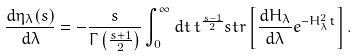Convert formula to latex. <formula><loc_0><loc_0><loc_500><loc_500>\frac { d \eta _ { \lambda } ( s ) } { d \lambda } = - \frac { s } { \Gamma \left ( \frac { s + 1 } { 2 } \right ) } \int _ { 0 } ^ { \infty } d t \, t ^ { \frac { s - 1 } { 2 } } s t r \left [ \frac { d H _ { \lambda } } { d \lambda } e ^ { - H _ { \lambda } ^ { 2 } t } \right ] .</formula> 